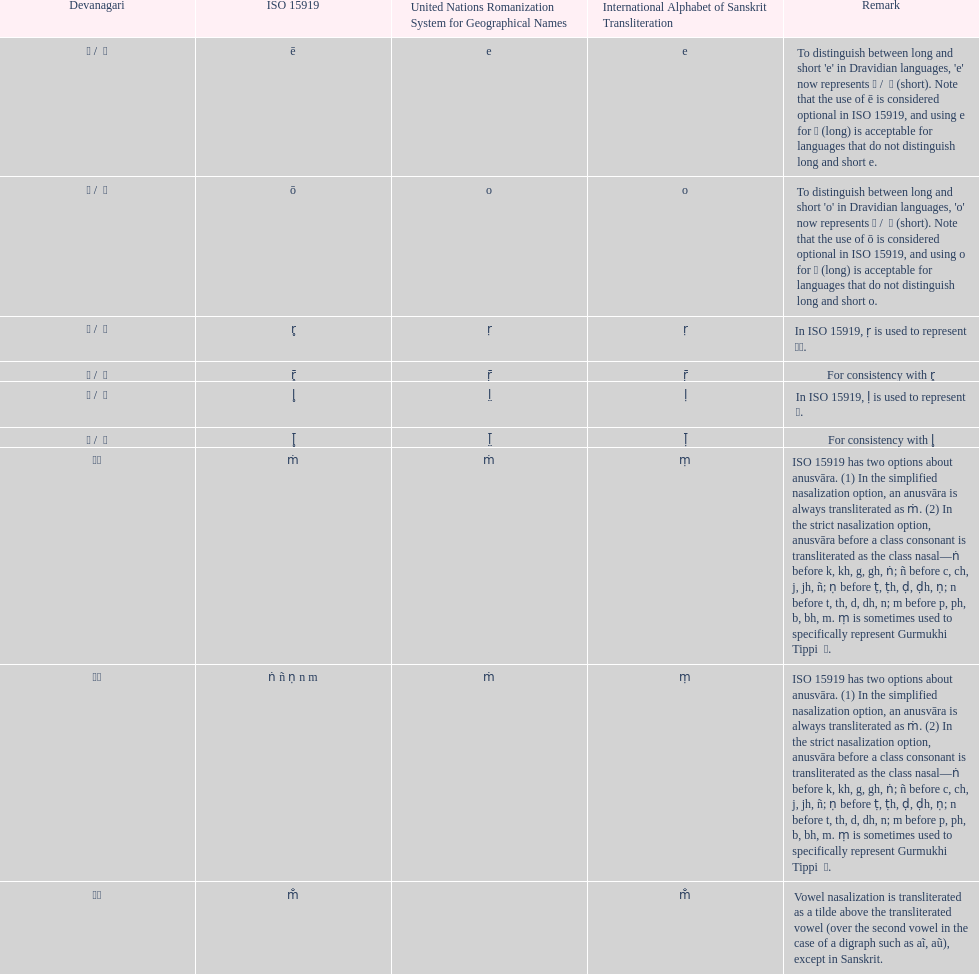What unrsgn is listed previous to the o? E. 